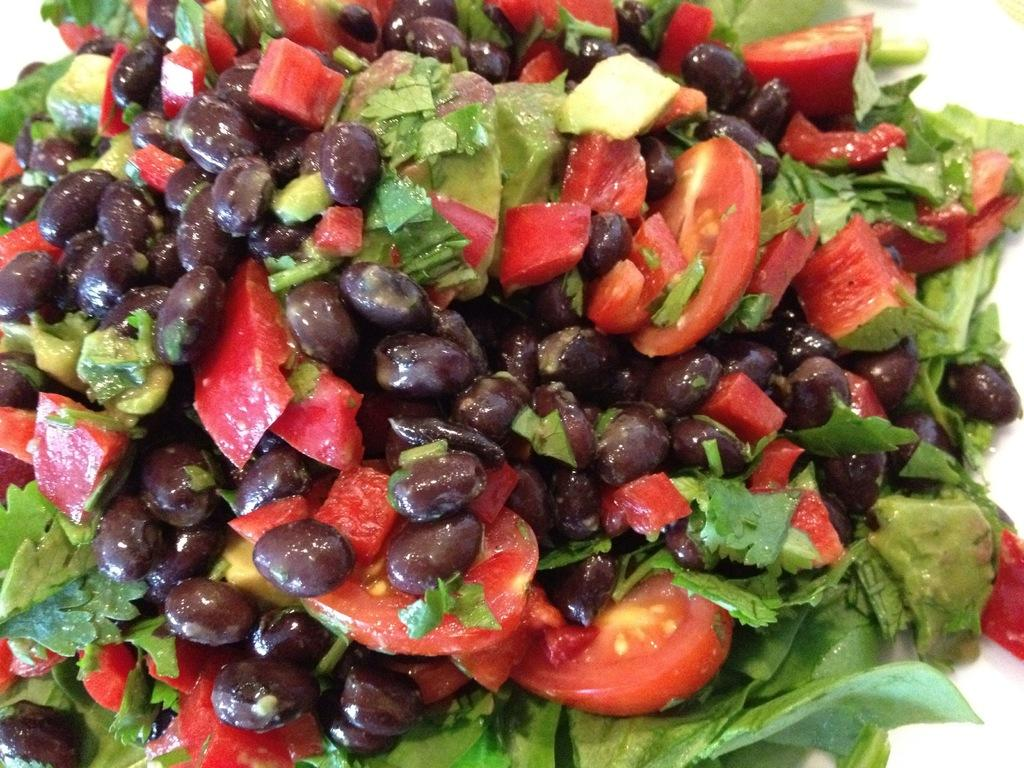What is the main subject of the image? The main subject of the image is food items. Can you identify any specific food items in the image? Yes, tomato slices and leafy vegetables are present among the food items. What type of jewel is being held by the farmer in the image? There is no farmer or jewel present in the image; it features food items with tomato slices and leafy vegetables. 